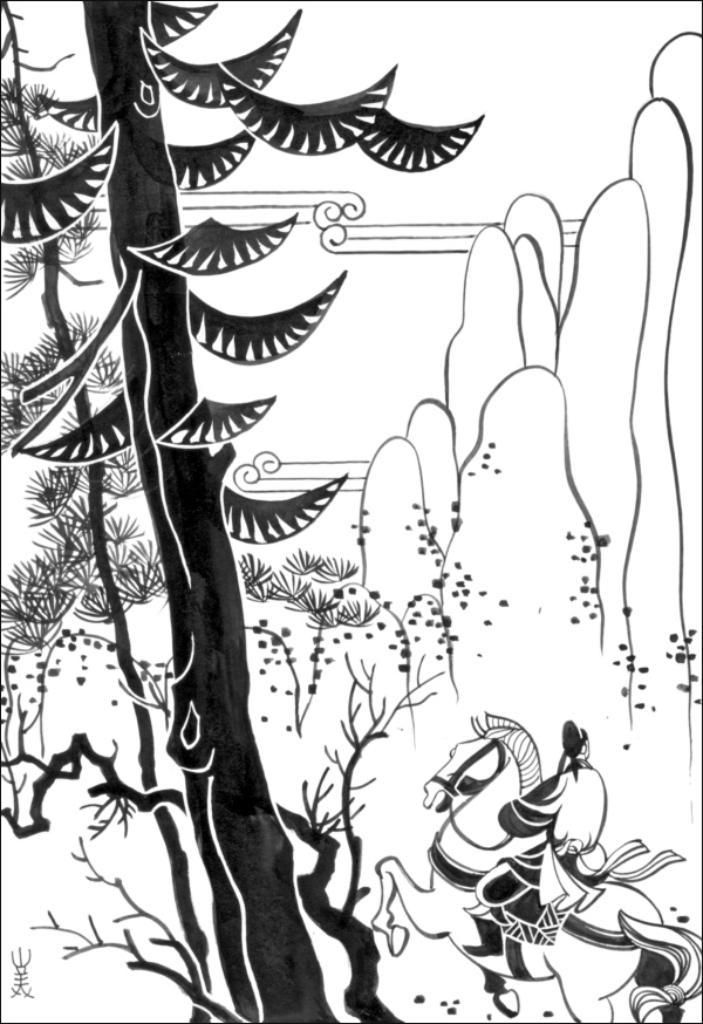What is the main subject of the image? The main subject of the image is a drawing. What elements are included in the drawing? The drawing contains trees. Can you describe the activity taking place in the bottom right corner of the image? There is a person riding a horse in the bottom right corner of the image. How many balls are being used by the person riding the horse in the image? There are no balls present in the image; the person riding the horse is not using any balls. 